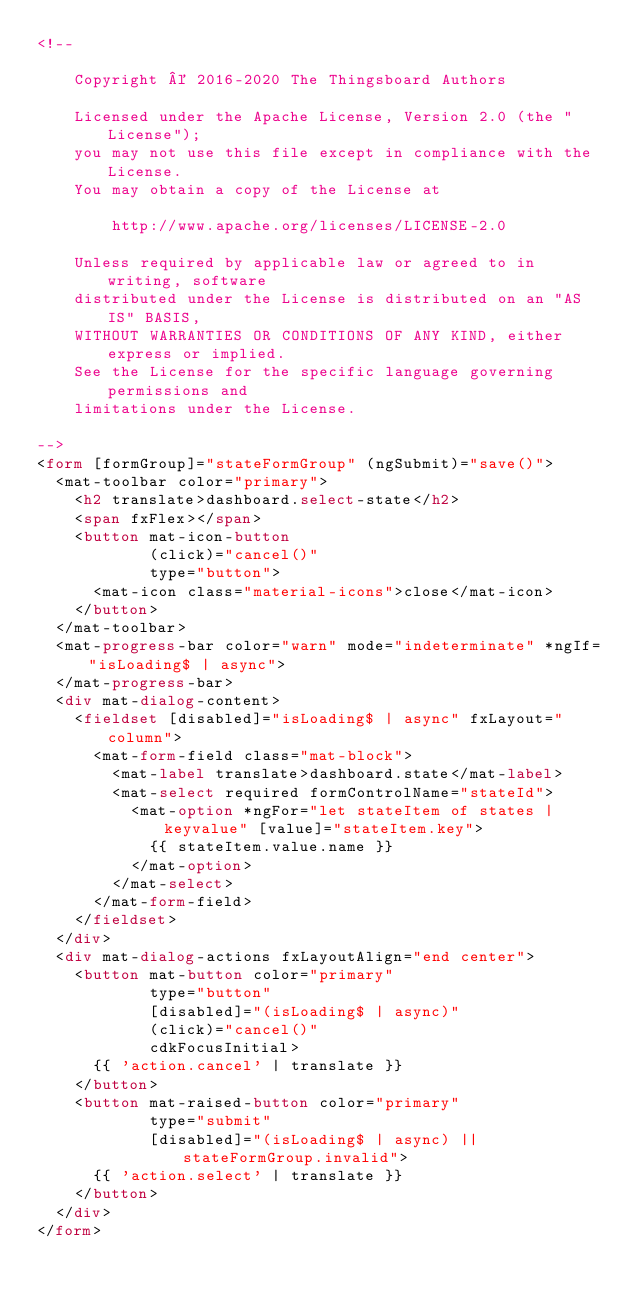Convert code to text. <code><loc_0><loc_0><loc_500><loc_500><_HTML_><!--

    Copyright © 2016-2020 The Thingsboard Authors

    Licensed under the Apache License, Version 2.0 (the "License");
    you may not use this file except in compliance with the License.
    You may obtain a copy of the License at

        http://www.apache.org/licenses/LICENSE-2.0

    Unless required by applicable law or agreed to in writing, software
    distributed under the License is distributed on an "AS IS" BASIS,
    WITHOUT WARRANTIES OR CONDITIONS OF ANY KIND, either express or implied.
    See the License for the specific language governing permissions and
    limitations under the License.

-->
<form [formGroup]="stateFormGroup" (ngSubmit)="save()">
  <mat-toolbar color="primary">
    <h2 translate>dashboard.select-state</h2>
    <span fxFlex></span>
    <button mat-icon-button
            (click)="cancel()"
            type="button">
      <mat-icon class="material-icons">close</mat-icon>
    </button>
  </mat-toolbar>
  <mat-progress-bar color="warn" mode="indeterminate" *ngIf="isLoading$ | async">
  </mat-progress-bar>
  <div mat-dialog-content>
    <fieldset [disabled]="isLoading$ | async" fxLayout="column">
      <mat-form-field class="mat-block">
        <mat-label translate>dashboard.state</mat-label>
        <mat-select required formControlName="stateId">
          <mat-option *ngFor="let stateItem of states | keyvalue" [value]="stateItem.key">
            {{ stateItem.value.name }}
          </mat-option>
        </mat-select>
      </mat-form-field>
    </fieldset>
  </div>
  <div mat-dialog-actions fxLayoutAlign="end center">
    <button mat-button color="primary"
            type="button"
            [disabled]="(isLoading$ | async)"
            (click)="cancel()"
            cdkFocusInitial>
      {{ 'action.cancel' | translate }}
    </button>
    <button mat-raised-button color="primary"
            type="submit"
            [disabled]="(isLoading$ | async) || stateFormGroup.invalid">
      {{ 'action.select' | translate }}
    </button>
  </div>
</form>
</code> 